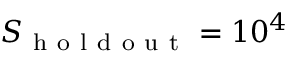<formula> <loc_0><loc_0><loc_500><loc_500>S _ { h o l d o u t } = 1 0 ^ { 4 }</formula> 